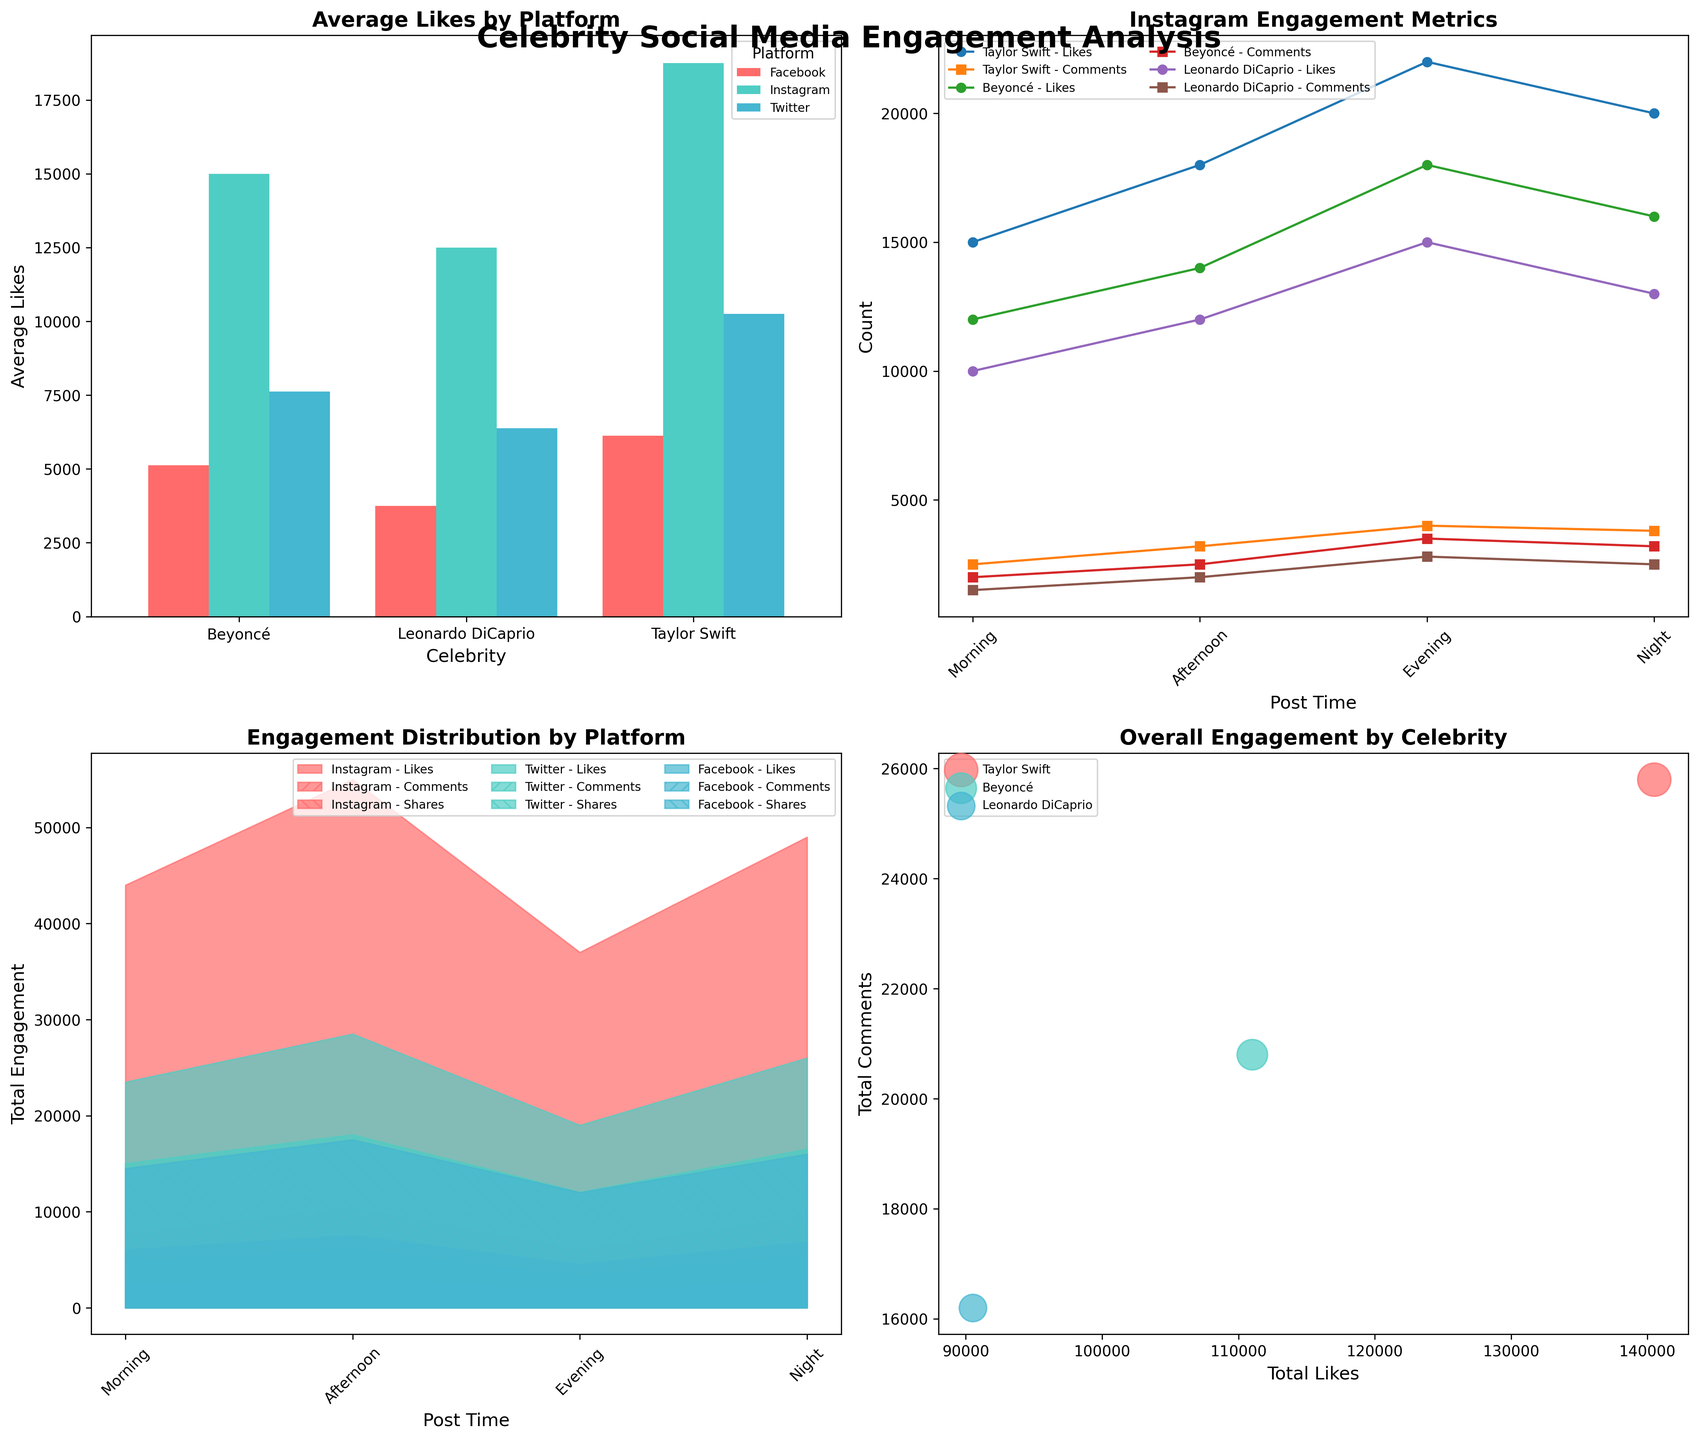What's the average number of likes on Instagram for Taylor Swift compared to Beyoncé? To find this, look at the "Average Likes by Platform" bar chart. Locate the bars corresponding to Taylor Swift and Beyoncé for Instagram, and compare the heights visually.
Answer: Taylor Swift has higher average likes on Instagram than Beyoncé At what post time does Taylor Swift receive the highest number of likes on Instagram? Refer to the "Instagram Engagement Metrics" line plot. Look at the likes line for Taylor Swift and find the post time where the peak occurs.
Answer: Evening Which celebrity has the most comments on Twitter during the evening? In the "Engagement Distribution by Platform" subplot, identify the overall height of the filled area for comments on Twitter during the evening. Again, for a more specific check, refer to the corresponding segment in the bar chart.
Answer: Taylor Swift How do the total engagements (likes, comments, shares) change for Beyoncé on Twitter from morning to night? From morning to night, follow Beyoncé's lines in the "Instagram Engagement Metrics" for Twitter. Notice the changes in the lines for likes, comments, and shares. Summing these at each time point will show the pattern.
Answer: Increase What is the difference in total comments between Facebook and Twitter for Leonardo DiCaprio? In the "Engagement Distribution by Platform" area chart, find the total height of the comments section for Leonardo DiCaprio on both Facebook and Twitter. Subtract the Facebook total from the Twitter total.
Answer: Twitter has more comments than Facebook Which platform shows the most significant variation in engagement metrics across all celebrities? This can be deduced by observing the "Total Engagement Distribution by Platform" subplot and identifying the platform with the largest variations in the areas covered by likes, comments, and shares.
Answer: Instagram Which celebrity has the lowest total shares across all platforms? Refer to the "Overall Engagement by Celebrity" bubble chart. The celebrity with the smallest bubbles (shares contribute to bubble size) indicates the lowest total shares.
Answer: Leonardo DiCaprio Do the post timings affect the likes more on Instagram or Twitter for Beyoncé? Compare the slope of Beyoncé's likes lines over different post times in the "Instagram Engagement Metrics" line plot filtered for Instagram and Twitter. Steeper slopes indicate more significant changes.
Answer: Instagram How does the Instagram engagement for comments compare for Leonardo DiCaprio between morning and evening? Check Leonardo DiCaprio's comments line in the "Instagram Engagement Metrics" line plot. Find values for morning and evening and compare.
Answer: Evening is higher than morning What is the biggest bubble size in the "Overall Engagement by Celebrity" bubble chart and which celebrity does it belong to? Identify the largest bubble in the bubble chart by visually assessing size and label, representing the highest total shares.
Answer: Taylor Swift 